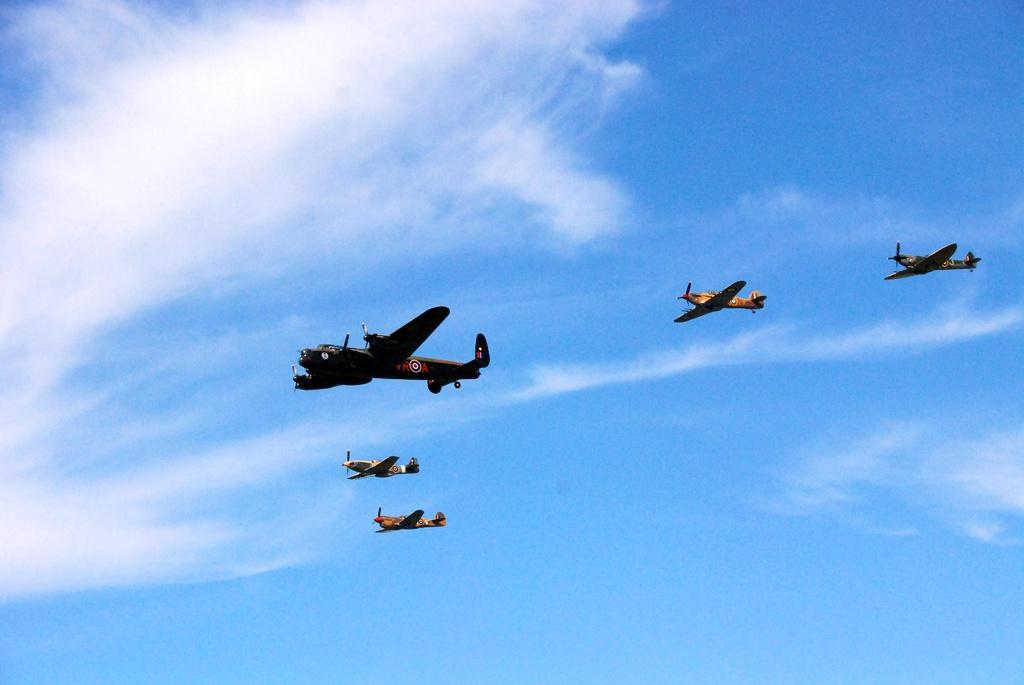What is the main subject of the image? The main subject of the image is aeroplanes. Where are the aeroplanes located in the image? The aeroplanes are in the air. What can be seen in the background of the image? There is sky visible in the background of the image. What is present in the sky? Clouds are present in the sky. What type of silver is being used to scare away birds on the slope in the image? There is no silver or slope present in the image; it features aeroplanes in the sky. What type of creature is shown interacting with the silver on the slope in the image? There is no creature, silver, or slope present in the image. 